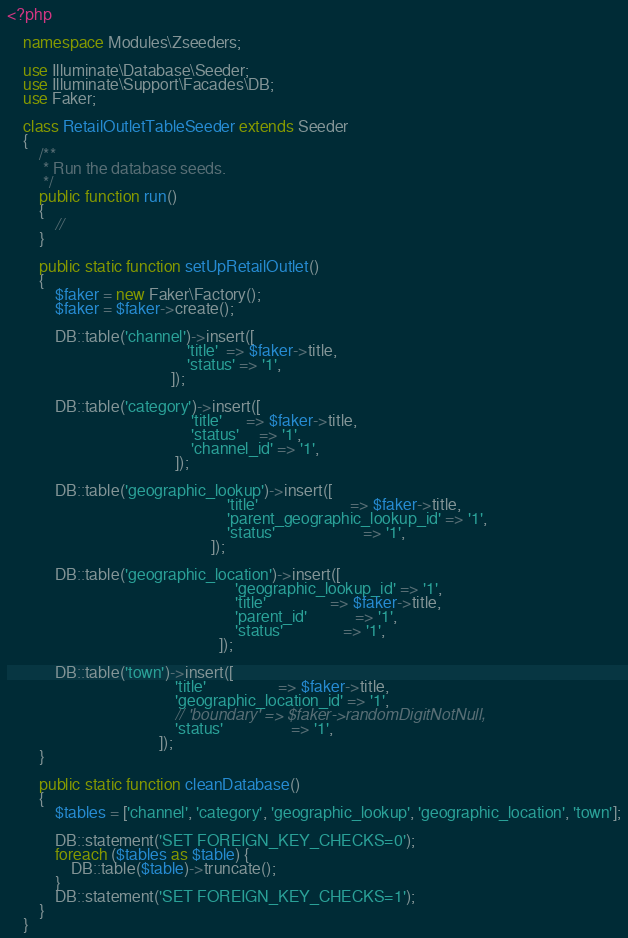Convert code to text. <code><loc_0><loc_0><loc_500><loc_500><_PHP_><?php

    namespace Modules\Zseeders;

    use Illuminate\Database\Seeder;
    use Illuminate\Support\Facades\DB;
    use Faker;

    class RetailOutletTableSeeder extends Seeder
    {
        /**
         * Run the database seeds.
         */
        public function run()
        {
            //
        }

        public static function setUpRetailOutlet()
        {
            $faker = new Faker\Factory();
            $faker = $faker->create();

            DB::table('channel')->insert([
                                             'title'  => $faker->title,
                                             'status' => '1',
                                         ]);

            DB::table('category')->insert([
                                              'title'      => $faker->title,
                                              'status'     => '1',
                                              'channel_id' => '1',
                                          ]);

            DB::table('geographic_lookup')->insert([
                                                       'title'                       => $faker->title,
                                                       'parent_geographic_lookup_id' => '1',
                                                       'status'                      => '1',
                                                   ]);

            DB::table('geographic_location')->insert([
                                                         'geographic_lookup_id' => '1',
                                                         'title'                => $faker->title,
                                                         'parent_id'            => '1',
                                                         'status'               => '1',
                                                     ]);

            DB::table('town')->insert([
                                          'title'                  => $faker->title,
                                          'geographic_location_id' => '1',
                                          // 'boundary' => $faker->randomDigitNotNull,
                                          'status'                 => '1',
                                      ]);
        }

        public static function cleanDatabase()
        {
            $tables = ['channel', 'category', 'geographic_lookup', 'geographic_location', 'town'];

            DB::statement('SET FOREIGN_KEY_CHECKS=0');
            foreach ($tables as $table) {
                DB::table($table)->truncate();
            }
            DB::statement('SET FOREIGN_KEY_CHECKS=1');
        }
    }
</code> 